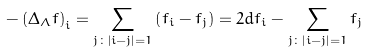Convert formula to latex. <formula><loc_0><loc_0><loc_500><loc_500>- \left ( \Delta _ { \Lambda } f \right ) _ { i } = \sum _ { j \colon \left | i - j \right | = 1 } \left ( f _ { i } - f _ { j } \right ) = 2 d f _ { i } - \sum _ { j \colon \left | i - j \right | = 1 } f _ { j }</formula> 